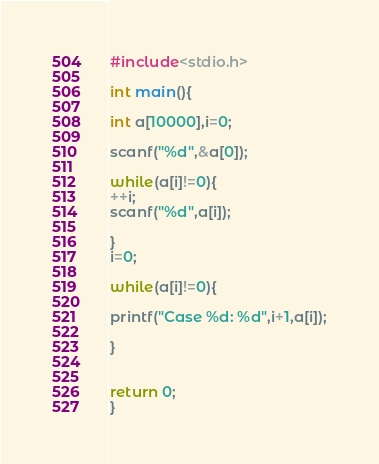Convert code to text. <code><loc_0><loc_0><loc_500><loc_500><_C_>#include<stdio.h>

int main(){

int a[10000],i=0;

scanf("%d",&a[0]);

while(a[i]!=0){
++i;
scanf("%d",a[i]);

}
i=0;

while(a[i]!=0){

printf("Case %d: %d",i+1,a[i]);

}


return 0;
}</code> 